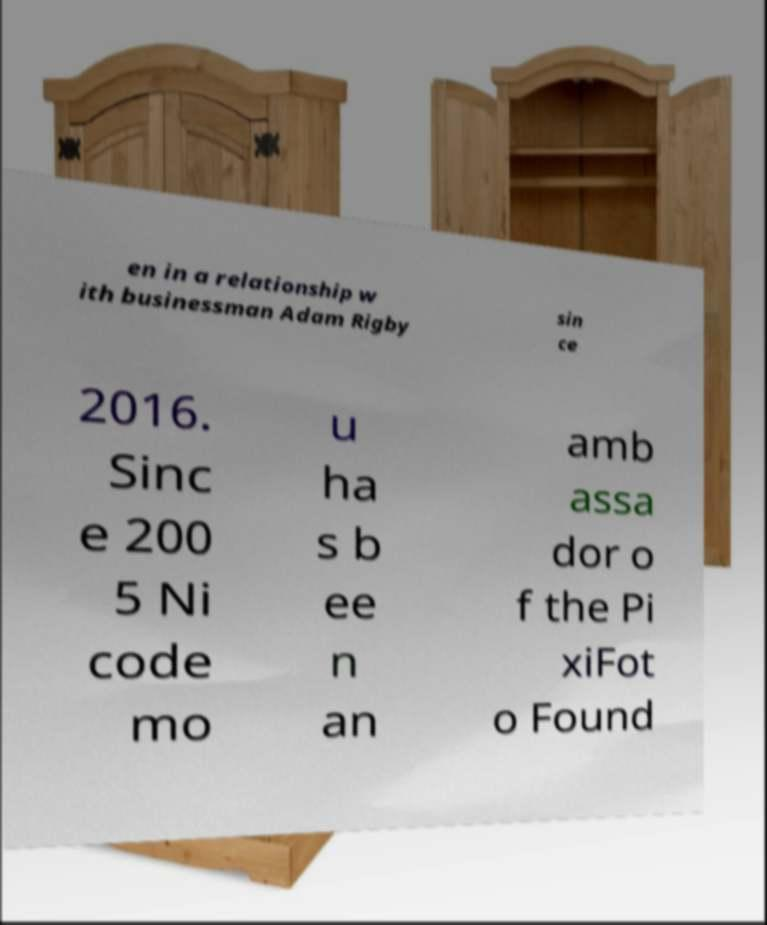I need the written content from this picture converted into text. Can you do that? en in a relationship w ith businessman Adam Rigby sin ce 2016. Sinc e 200 5 Ni code mo u ha s b ee n an amb assa dor o f the Pi xiFot o Found 